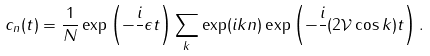<formula> <loc_0><loc_0><loc_500><loc_500>c _ { n } ( t ) = \frac { 1 } { N } \exp \left ( - \frac { i } { } \epsilon t \right ) \sum _ { k } \exp ( i k n ) \exp \left ( - \frac { i } { } ( 2 \mathcal { V } \cos k ) t \right ) .</formula> 